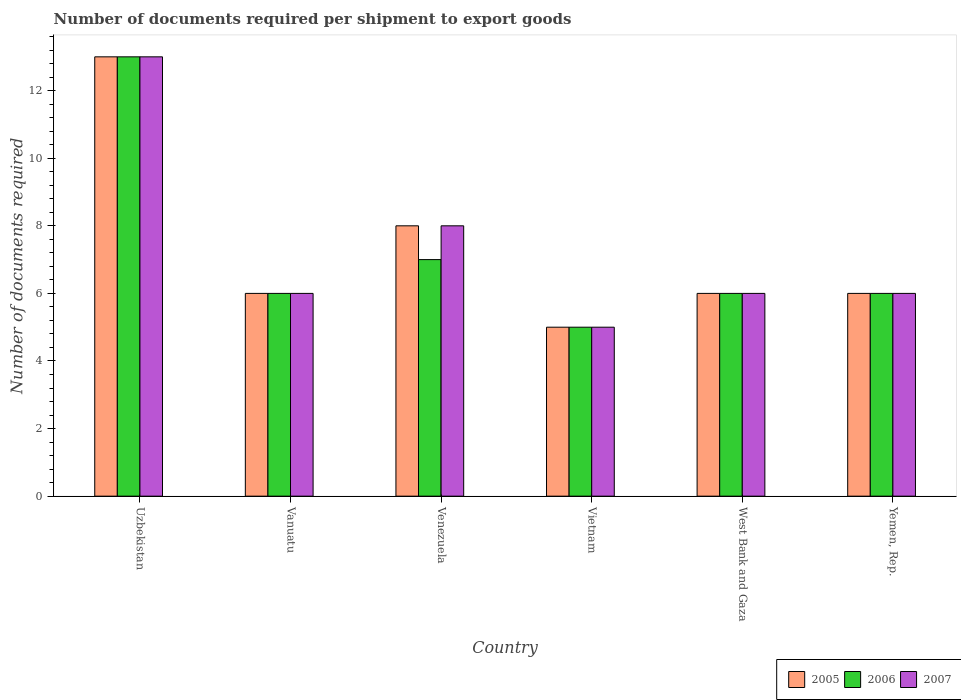How many groups of bars are there?
Your answer should be very brief. 6. What is the label of the 2nd group of bars from the left?
Ensure brevity in your answer.  Vanuatu. What is the number of documents required per shipment to export goods in 2006 in Vanuatu?
Your answer should be very brief. 6. In which country was the number of documents required per shipment to export goods in 2007 maximum?
Ensure brevity in your answer.  Uzbekistan. In which country was the number of documents required per shipment to export goods in 2006 minimum?
Your answer should be very brief. Vietnam. What is the difference between the number of documents required per shipment to export goods in 2005 in Uzbekistan and the number of documents required per shipment to export goods in 2006 in Vietnam?
Your answer should be compact. 8. What is the average number of documents required per shipment to export goods in 2007 per country?
Make the answer very short. 7.33. In how many countries, is the number of documents required per shipment to export goods in 2007 greater than 2.4?
Ensure brevity in your answer.  6. What is the ratio of the number of documents required per shipment to export goods in 2006 in Vietnam to that in West Bank and Gaza?
Your response must be concise. 0.83. Is the number of documents required per shipment to export goods in 2007 in Venezuela less than that in Vietnam?
Make the answer very short. No. What is the difference between the highest and the second highest number of documents required per shipment to export goods in 2007?
Ensure brevity in your answer.  -5. What does the 1st bar from the right in Uzbekistan represents?
Provide a succinct answer. 2007. Are all the bars in the graph horizontal?
Give a very brief answer. No. How many legend labels are there?
Offer a very short reply. 3. How are the legend labels stacked?
Your response must be concise. Horizontal. What is the title of the graph?
Your answer should be very brief. Number of documents required per shipment to export goods. Does "1996" appear as one of the legend labels in the graph?
Ensure brevity in your answer.  No. What is the label or title of the X-axis?
Keep it short and to the point. Country. What is the label or title of the Y-axis?
Your answer should be very brief. Number of documents required. What is the Number of documents required of 2005 in Uzbekistan?
Give a very brief answer. 13. What is the Number of documents required in 2006 in Uzbekistan?
Ensure brevity in your answer.  13. What is the Number of documents required of 2007 in Uzbekistan?
Offer a terse response. 13. What is the Number of documents required of 2005 in Vanuatu?
Provide a short and direct response. 6. What is the Number of documents required of 2007 in Vanuatu?
Give a very brief answer. 6. What is the Number of documents required of 2005 in Venezuela?
Provide a short and direct response. 8. What is the Number of documents required in 2006 in Venezuela?
Your answer should be very brief. 7. What is the Number of documents required of 2007 in Venezuela?
Keep it short and to the point. 8. What is the Number of documents required in 2006 in Vietnam?
Offer a terse response. 5. What is the Number of documents required in 2005 in Yemen, Rep.?
Make the answer very short. 6. What is the Number of documents required of 2006 in Yemen, Rep.?
Give a very brief answer. 6. What is the Number of documents required of 2007 in Yemen, Rep.?
Ensure brevity in your answer.  6. Across all countries, what is the maximum Number of documents required of 2006?
Keep it short and to the point. 13. Across all countries, what is the minimum Number of documents required of 2007?
Provide a short and direct response. 5. What is the total Number of documents required in 2006 in the graph?
Make the answer very short. 43. What is the total Number of documents required of 2007 in the graph?
Offer a very short reply. 44. What is the difference between the Number of documents required of 2007 in Uzbekistan and that in Vanuatu?
Offer a terse response. 7. What is the difference between the Number of documents required of 2005 in Uzbekistan and that in Venezuela?
Keep it short and to the point. 5. What is the difference between the Number of documents required in 2006 in Uzbekistan and that in Venezuela?
Offer a terse response. 6. What is the difference between the Number of documents required of 2006 in Uzbekistan and that in Vietnam?
Your answer should be compact. 8. What is the difference between the Number of documents required of 2007 in Uzbekistan and that in Vietnam?
Offer a terse response. 8. What is the difference between the Number of documents required in 2005 in Uzbekistan and that in West Bank and Gaza?
Your response must be concise. 7. What is the difference between the Number of documents required of 2006 in Uzbekistan and that in West Bank and Gaza?
Make the answer very short. 7. What is the difference between the Number of documents required of 2007 in Uzbekistan and that in West Bank and Gaza?
Offer a terse response. 7. What is the difference between the Number of documents required of 2006 in Uzbekistan and that in Yemen, Rep.?
Give a very brief answer. 7. What is the difference between the Number of documents required of 2005 in Vanuatu and that in Venezuela?
Make the answer very short. -2. What is the difference between the Number of documents required in 2006 in Vanuatu and that in Venezuela?
Make the answer very short. -1. What is the difference between the Number of documents required of 2007 in Vanuatu and that in Venezuela?
Ensure brevity in your answer.  -2. What is the difference between the Number of documents required of 2006 in Vanuatu and that in Vietnam?
Offer a very short reply. 1. What is the difference between the Number of documents required of 2006 in Vanuatu and that in West Bank and Gaza?
Your response must be concise. 0. What is the difference between the Number of documents required in 2007 in Vanuatu and that in West Bank and Gaza?
Your answer should be very brief. 0. What is the difference between the Number of documents required of 2005 in Vanuatu and that in Yemen, Rep.?
Make the answer very short. 0. What is the difference between the Number of documents required of 2006 in Vanuatu and that in Yemen, Rep.?
Give a very brief answer. 0. What is the difference between the Number of documents required of 2005 in Venezuela and that in Yemen, Rep.?
Your answer should be very brief. 2. What is the difference between the Number of documents required in 2006 in Vietnam and that in West Bank and Gaza?
Give a very brief answer. -1. What is the difference between the Number of documents required in 2007 in Vietnam and that in West Bank and Gaza?
Offer a very short reply. -1. What is the difference between the Number of documents required in 2006 in Vietnam and that in Yemen, Rep.?
Provide a succinct answer. -1. What is the difference between the Number of documents required of 2007 in Vietnam and that in Yemen, Rep.?
Keep it short and to the point. -1. What is the difference between the Number of documents required in 2006 in West Bank and Gaza and that in Yemen, Rep.?
Offer a very short reply. 0. What is the difference between the Number of documents required in 2005 in Uzbekistan and the Number of documents required in 2007 in Venezuela?
Offer a terse response. 5. What is the difference between the Number of documents required in 2006 in Uzbekistan and the Number of documents required in 2007 in Venezuela?
Offer a very short reply. 5. What is the difference between the Number of documents required of 2005 in Uzbekistan and the Number of documents required of 2006 in West Bank and Gaza?
Provide a succinct answer. 7. What is the difference between the Number of documents required of 2005 in Uzbekistan and the Number of documents required of 2006 in Yemen, Rep.?
Keep it short and to the point. 7. What is the difference between the Number of documents required of 2006 in Uzbekistan and the Number of documents required of 2007 in Yemen, Rep.?
Give a very brief answer. 7. What is the difference between the Number of documents required in 2005 in Vanuatu and the Number of documents required in 2006 in Venezuela?
Keep it short and to the point. -1. What is the difference between the Number of documents required in 2005 in Vanuatu and the Number of documents required in 2007 in Venezuela?
Your answer should be compact. -2. What is the difference between the Number of documents required in 2005 in Vanuatu and the Number of documents required in 2007 in Vietnam?
Make the answer very short. 1. What is the difference between the Number of documents required in 2006 in Vanuatu and the Number of documents required in 2007 in Vietnam?
Make the answer very short. 1. What is the difference between the Number of documents required in 2005 in Venezuela and the Number of documents required in 2007 in Vietnam?
Ensure brevity in your answer.  3. What is the difference between the Number of documents required in 2006 in Venezuela and the Number of documents required in 2007 in Vietnam?
Offer a very short reply. 2. What is the difference between the Number of documents required in 2006 in Venezuela and the Number of documents required in 2007 in West Bank and Gaza?
Make the answer very short. 1. What is the difference between the Number of documents required of 2005 in Venezuela and the Number of documents required of 2006 in Yemen, Rep.?
Ensure brevity in your answer.  2. What is the difference between the Number of documents required in 2005 in Venezuela and the Number of documents required in 2007 in Yemen, Rep.?
Offer a terse response. 2. What is the difference between the Number of documents required of 2005 in Vietnam and the Number of documents required of 2006 in West Bank and Gaza?
Your response must be concise. -1. What is the difference between the Number of documents required of 2005 in Vietnam and the Number of documents required of 2006 in Yemen, Rep.?
Offer a terse response. -1. What is the difference between the Number of documents required of 2006 in Vietnam and the Number of documents required of 2007 in Yemen, Rep.?
Offer a terse response. -1. What is the difference between the Number of documents required in 2005 in West Bank and Gaza and the Number of documents required in 2007 in Yemen, Rep.?
Keep it short and to the point. 0. What is the average Number of documents required in 2005 per country?
Make the answer very short. 7.33. What is the average Number of documents required of 2006 per country?
Your answer should be compact. 7.17. What is the average Number of documents required in 2007 per country?
Make the answer very short. 7.33. What is the difference between the Number of documents required in 2005 and Number of documents required in 2007 in Vanuatu?
Your response must be concise. 0. What is the difference between the Number of documents required in 2006 and Number of documents required in 2007 in Vanuatu?
Your answer should be very brief. 0. What is the difference between the Number of documents required in 2005 and Number of documents required in 2006 in Venezuela?
Provide a short and direct response. 1. What is the difference between the Number of documents required of 2006 and Number of documents required of 2007 in Venezuela?
Provide a succinct answer. -1. What is the difference between the Number of documents required of 2005 and Number of documents required of 2007 in Vietnam?
Ensure brevity in your answer.  0. What is the difference between the Number of documents required in 2005 and Number of documents required in 2006 in West Bank and Gaza?
Your answer should be compact. 0. What is the difference between the Number of documents required of 2005 and Number of documents required of 2007 in West Bank and Gaza?
Offer a very short reply. 0. What is the difference between the Number of documents required of 2006 and Number of documents required of 2007 in West Bank and Gaza?
Your answer should be very brief. 0. What is the difference between the Number of documents required in 2005 and Number of documents required in 2007 in Yemen, Rep.?
Your answer should be compact. 0. What is the ratio of the Number of documents required of 2005 in Uzbekistan to that in Vanuatu?
Make the answer very short. 2.17. What is the ratio of the Number of documents required of 2006 in Uzbekistan to that in Vanuatu?
Ensure brevity in your answer.  2.17. What is the ratio of the Number of documents required in 2007 in Uzbekistan to that in Vanuatu?
Your response must be concise. 2.17. What is the ratio of the Number of documents required in 2005 in Uzbekistan to that in Venezuela?
Your answer should be very brief. 1.62. What is the ratio of the Number of documents required of 2006 in Uzbekistan to that in Venezuela?
Your response must be concise. 1.86. What is the ratio of the Number of documents required of 2007 in Uzbekistan to that in Venezuela?
Keep it short and to the point. 1.62. What is the ratio of the Number of documents required in 2006 in Uzbekistan to that in Vietnam?
Your response must be concise. 2.6. What is the ratio of the Number of documents required of 2007 in Uzbekistan to that in Vietnam?
Give a very brief answer. 2.6. What is the ratio of the Number of documents required in 2005 in Uzbekistan to that in West Bank and Gaza?
Offer a terse response. 2.17. What is the ratio of the Number of documents required of 2006 in Uzbekistan to that in West Bank and Gaza?
Offer a very short reply. 2.17. What is the ratio of the Number of documents required of 2007 in Uzbekistan to that in West Bank and Gaza?
Provide a succinct answer. 2.17. What is the ratio of the Number of documents required of 2005 in Uzbekistan to that in Yemen, Rep.?
Your answer should be compact. 2.17. What is the ratio of the Number of documents required of 2006 in Uzbekistan to that in Yemen, Rep.?
Keep it short and to the point. 2.17. What is the ratio of the Number of documents required in 2007 in Uzbekistan to that in Yemen, Rep.?
Offer a terse response. 2.17. What is the ratio of the Number of documents required of 2006 in Vanuatu to that in Venezuela?
Give a very brief answer. 0.86. What is the ratio of the Number of documents required in 2007 in Vanuatu to that in Venezuela?
Your response must be concise. 0.75. What is the ratio of the Number of documents required of 2005 in Vanuatu to that in Vietnam?
Make the answer very short. 1.2. What is the ratio of the Number of documents required in 2005 in Vanuatu to that in West Bank and Gaza?
Keep it short and to the point. 1. What is the ratio of the Number of documents required in 2006 in Vanuatu to that in West Bank and Gaza?
Ensure brevity in your answer.  1. What is the ratio of the Number of documents required in 2006 in Vanuatu to that in Yemen, Rep.?
Make the answer very short. 1. What is the ratio of the Number of documents required of 2007 in Vanuatu to that in Yemen, Rep.?
Give a very brief answer. 1. What is the ratio of the Number of documents required in 2005 in Venezuela to that in West Bank and Gaza?
Your response must be concise. 1.33. What is the ratio of the Number of documents required in 2006 in Venezuela to that in West Bank and Gaza?
Your answer should be compact. 1.17. What is the ratio of the Number of documents required in 2007 in Venezuela to that in West Bank and Gaza?
Your response must be concise. 1.33. What is the ratio of the Number of documents required of 2005 in Venezuela to that in Yemen, Rep.?
Keep it short and to the point. 1.33. What is the ratio of the Number of documents required of 2005 in Vietnam to that in West Bank and Gaza?
Your answer should be compact. 0.83. What is the ratio of the Number of documents required in 2006 in Vietnam to that in West Bank and Gaza?
Keep it short and to the point. 0.83. What is the ratio of the Number of documents required in 2007 in Vietnam to that in West Bank and Gaza?
Offer a very short reply. 0.83. What is the ratio of the Number of documents required in 2006 in Vietnam to that in Yemen, Rep.?
Provide a succinct answer. 0.83. What is the ratio of the Number of documents required in 2006 in West Bank and Gaza to that in Yemen, Rep.?
Your answer should be compact. 1. What is the difference between the highest and the second highest Number of documents required of 2006?
Your answer should be compact. 6. What is the difference between the highest and the second highest Number of documents required in 2007?
Your answer should be compact. 5. What is the difference between the highest and the lowest Number of documents required in 2006?
Provide a succinct answer. 8. 